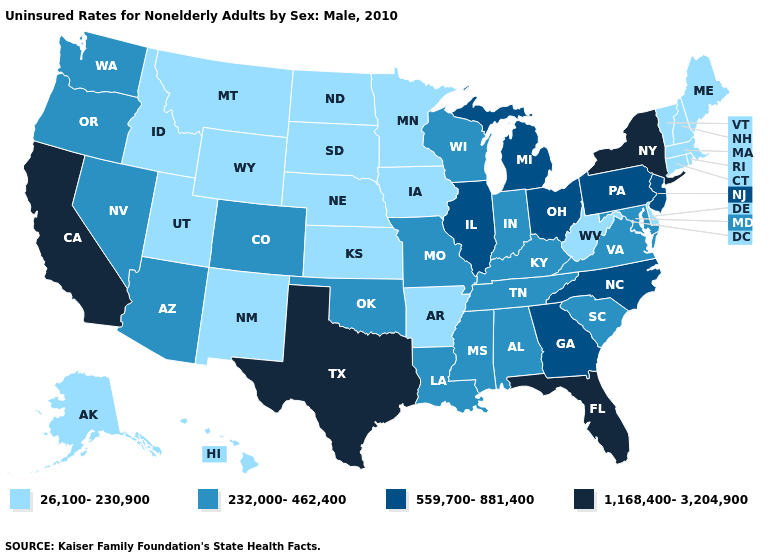Name the states that have a value in the range 559,700-881,400?
Concise answer only. Georgia, Illinois, Michigan, New Jersey, North Carolina, Ohio, Pennsylvania. What is the value of California?
Give a very brief answer. 1,168,400-3,204,900. What is the value of Alabama?
Concise answer only. 232,000-462,400. What is the lowest value in the Northeast?
Give a very brief answer. 26,100-230,900. Does the first symbol in the legend represent the smallest category?
Quick response, please. Yes. What is the value of Wyoming?
Be succinct. 26,100-230,900. What is the highest value in the West ?
Short answer required. 1,168,400-3,204,900. What is the value of New York?
Answer briefly. 1,168,400-3,204,900. Does Pennsylvania have the lowest value in the Northeast?
Keep it brief. No. What is the value of Iowa?
Keep it brief. 26,100-230,900. What is the highest value in the USA?
Quick response, please. 1,168,400-3,204,900. What is the value of Utah?
Concise answer only. 26,100-230,900. Name the states that have a value in the range 26,100-230,900?
Keep it brief. Alaska, Arkansas, Connecticut, Delaware, Hawaii, Idaho, Iowa, Kansas, Maine, Massachusetts, Minnesota, Montana, Nebraska, New Hampshire, New Mexico, North Dakota, Rhode Island, South Dakota, Utah, Vermont, West Virginia, Wyoming. Does the first symbol in the legend represent the smallest category?
Keep it brief. Yes. What is the value of Tennessee?
Give a very brief answer. 232,000-462,400. 